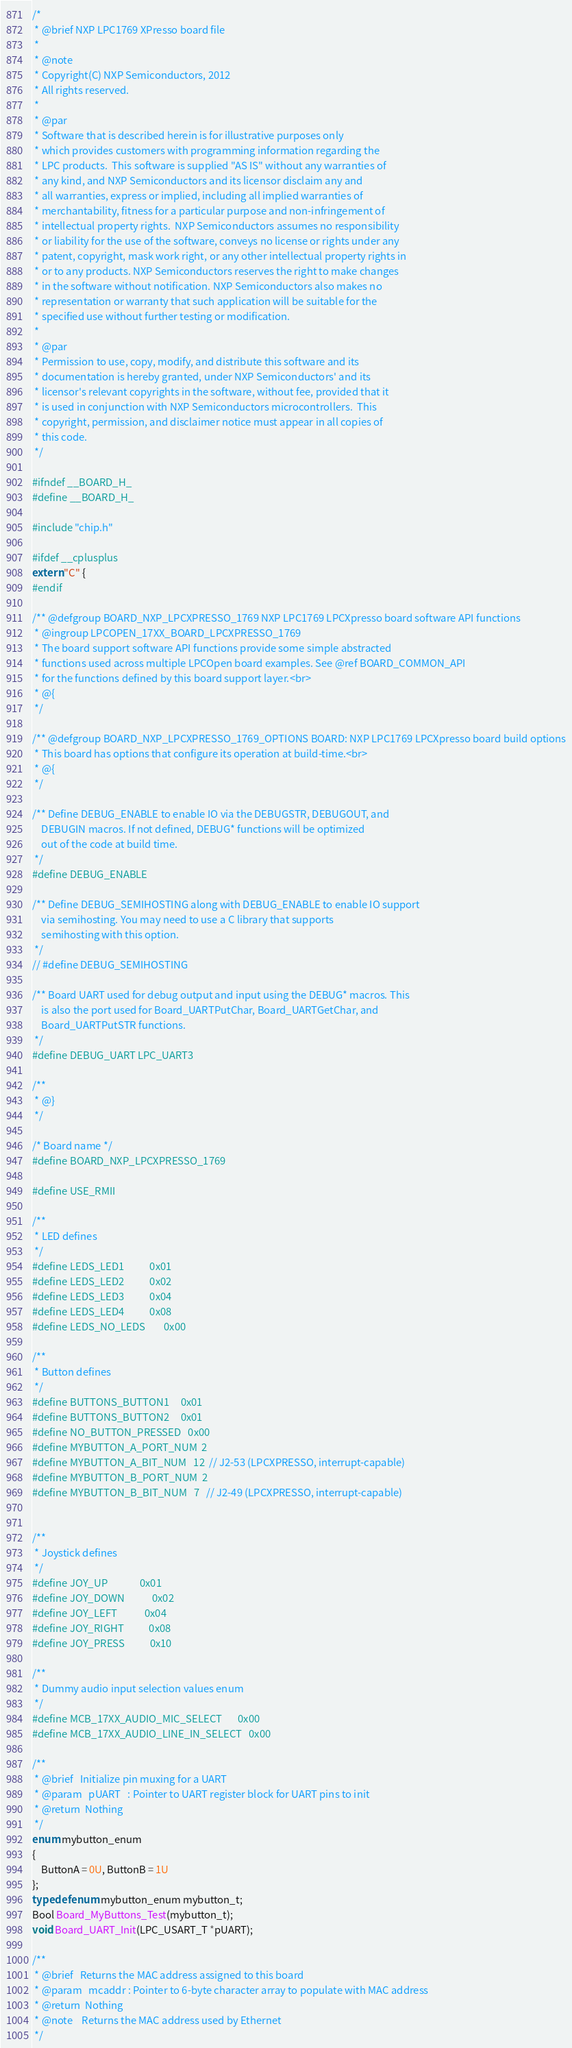<code> <loc_0><loc_0><loc_500><loc_500><_C_>/*
 * @brief NXP LPC1769 XPresso board file
 *
 * @note
 * Copyright(C) NXP Semiconductors, 2012
 * All rights reserved.
 *
 * @par
 * Software that is described herein is for illustrative purposes only
 * which provides customers with programming information regarding the
 * LPC products.  This software is supplied "AS IS" without any warranties of
 * any kind, and NXP Semiconductors and its licensor disclaim any and
 * all warranties, express or implied, including all implied warranties of
 * merchantability, fitness for a particular purpose and non-infringement of
 * intellectual property rights.  NXP Semiconductors assumes no responsibility
 * or liability for the use of the software, conveys no license or rights under any
 * patent, copyright, mask work right, or any other intellectual property rights in
 * or to any products. NXP Semiconductors reserves the right to make changes
 * in the software without notification. NXP Semiconductors also makes no
 * representation or warranty that such application will be suitable for the
 * specified use without further testing or modification.
 *
 * @par
 * Permission to use, copy, modify, and distribute this software and its
 * documentation is hereby granted, under NXP Semiconductors' and its
 * licensor's relevant copyrights in the software, without fee, provided that it
 * is used in conjunction with NXP Semiconductors microcontrollers.  This
 * copyright, permission, and disclaimer notice must appear in all copies of
 * this code.
 */

#ifndef __BOARD_H_
#define __BOARD_H_

#include "chip.h"

#ifdef __cplusplus
extern "C" {
#endif

/** @defgroup BOARD_NXP_LPCXPRESSO_1769 NXP LPC1769 LPCXpresso board software API functions
 * @ingroup LPCOPEN_17XX_BOARD_LPCXPRESSO_1769
 * The board support software API functions provide some simple abstracted
 * functions used across multiple LPCOpen board examples. See @ref BOARD_COMMON_API
 * for the functions defined by this board support layer.<br>
 * @{
 */

/** @defgroup BOARD_NXP_LPCXPRESSO_1769_OPTIONS BOARD: NXP LPC1769 LPCXpresso board build options
 * This board has options that configure its operation at build-time.<br>
 * @{
 */

/** Define DEBUG_ENABLE to enable IO via the DEBUGSTR, DEBUGOUT, and
    DEBUGIN macros. If not defined, DEBUG* functions will be optimized
    out of the code at build time.
 */
#define DEBUG_ENABLE

/** Define DEBUG_SEMIHOSTING along with DEBUG_ENABLE to enable IO support
    via semihosting. You may need to use a C library that supports
    semihosting with this option.
 */
// #define DEBUG_SEMIHOSTING

/** Board UART used for debug output and input using the DEBUG* macros. This
    is also the port used for Board_UARTPutChar, Board_UARTGetChar, and
    Board_UARTPutSTR functions.
 */
#define DEBUG_UART LPC_UART3

/**
 * @}
 */

/* Board name */
#define BOARD_NXP_LPCXPRESSO_1769

#define USE_RMII

/**
 * LED defines
 */
#define LEDS_LED1           0x01
#define LEDS_LED2           0x02
#define LEDS_LED3           0x04
#define LEDS_LED4           0x08
#define LEDS_NO_LEDS        0x00

/**
 * Button defines
 */
#define BUTTONS_BUTTON1     0x01
#define BUTTONS_BUTTON2     0x01
#define NO_BUTTON_PRESSED   0x00
#define MYBUTTON_A_PORT_NUM	2
#define MYBUTTON_A_BIT_NUM	12	// J2-53 (LPCXPRESSO, interrupt-capable)
#define MYBUTTON_B_PORT_NUM	2
#define MYBUTTON_B_BIT_NUM	7	// J2-49 (LPCXPRESSO, interrupt-capable)


/**
 * Joystick defines
 */
#define JOY_UP              0x01
#define JOY_DOWN            0x02
#define JOY_LEFT            0x04
#define JOY_RIGHT           0x08
#define JOY_PRESS           0x10

/**
 * Dummy audio input selection values enum
 */
#define MCB_17XX_AUDIO_MIC_SELECT       0x00
#define MCB_17XX_AUDIO_LINE_IN_SELECT   0x00

/**
 * @brief	Initialize pin muxing for a UART
 * @param	pUART	: Pointer to UART register block for UART pins to init
 * @return	Nothing
 */
enum mybutton_enum
{
	ButtonA = 0U, ButtonB = 1U
};
typedef enum mybutton_enum mybutton_t;
Bool Board_MyButtons_Test(mybutton_t);
void Board_UART_Init(LPC_USART_T *pUART);

/**
 * @brief	Returns the MAC address assigned to this board
 * @param	mcaddr : Pointer to 6-byte character array to populate with MAC address
 * @return	Nothing
 * @note    Returns the MAC address used by Ethernet
 */</code> 